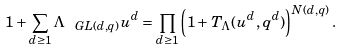<formula> <loc_0><loc_0><loc_500><loc_500>1 + \sum _ { d \geq 1 } \Lambda _ { \ G L ( d , q ) } u ^ { d } = \prod _ { d \geq 1 } \left ( 1 + T _ { \Lambda } ( u ^ { d } , q ^ { d } ) \right ) ^ { N ( d , q ) } .</formula> 